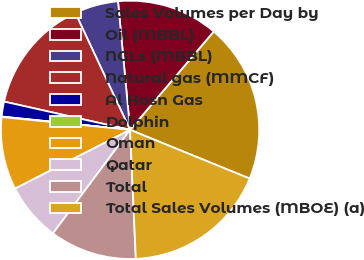Convert chart to OTSL. <chart><loc_0><loc_0><loc_500><loc_500><pie_chart><fcel>Sales Volumes per Day by<fcel>Oil (MBBL)<fcel>NGLs (MBBL)<fcel>Natural gas (MMCF)<fcel>Al Hosn Gas<fcel>Dolphin<fcel>Oman<fcel>Qatar<fcel>Total<fcel>Total Sales Volumes (MBOE) (a)<nl><fcel>19.94%<fcel>12.71%<fcel>5.48%<fcel>14.52%<fcel>1.87%<fcel>0.06%<fcel>9.1%<fcel>7.29%<fcel>10.9%<fcel>18.13%<nl></chart> 